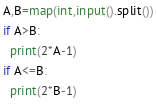<code> <loc_0><loc_0><loc_500><loc_500><_Python_>A,B=map(int,input().split())
if A>B:
  print(2*A-1)
if A<=B:
  print(2*B-1)</code> 